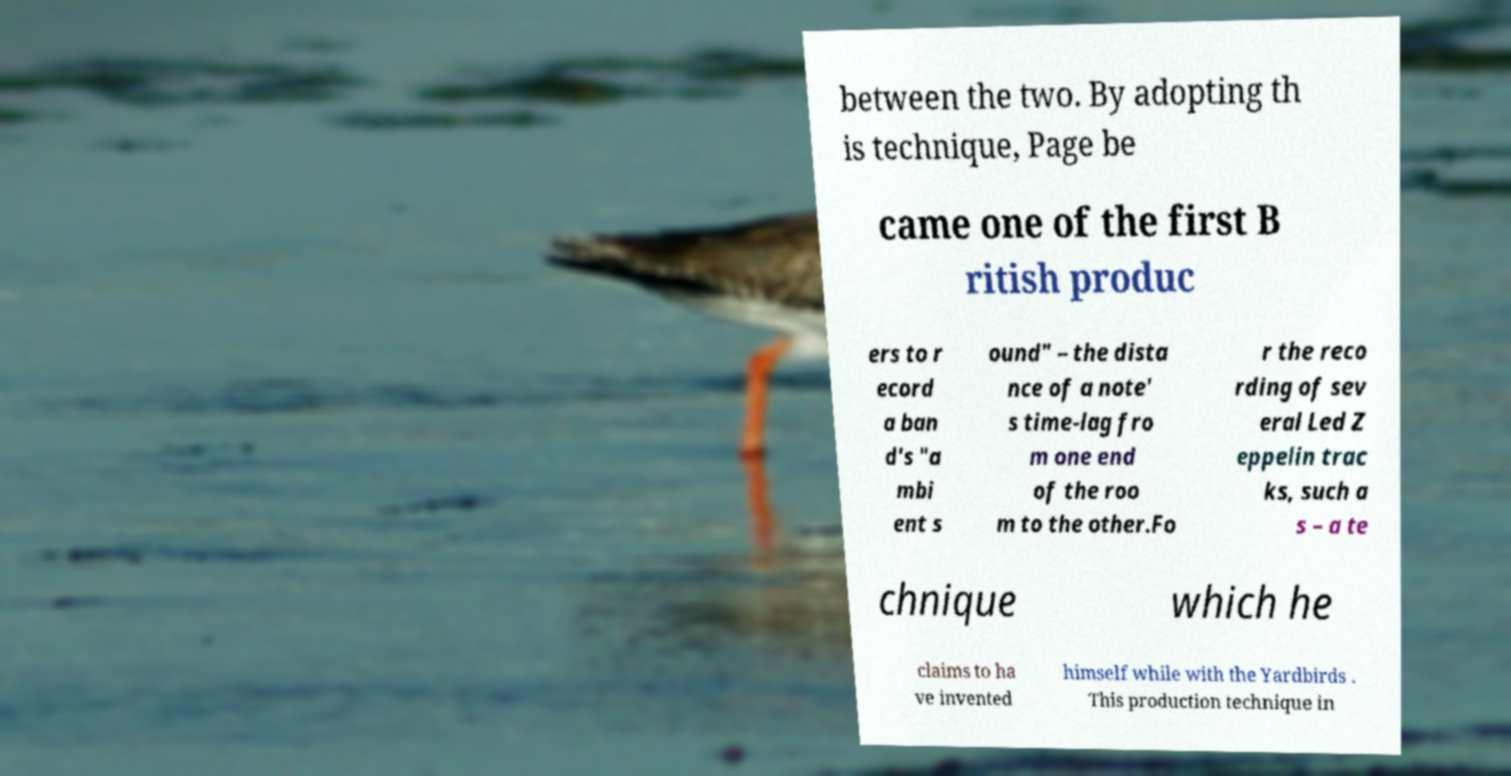I need the written content from this picture converted into text. Can you do that? between the two. By adopting th is technique, Page be came one of the first B ritish produc ers to r ecord a ban d's "a mbi ent s ound" – the dista nce of a note' s time-lag fro m one end of the roo m to the other.Fo r the reco rding of sev eral Led Z eppelin trac ks, such a s – a te chnique which he claims to ha ve invented himself while with the Yardbirds . This production technique in 